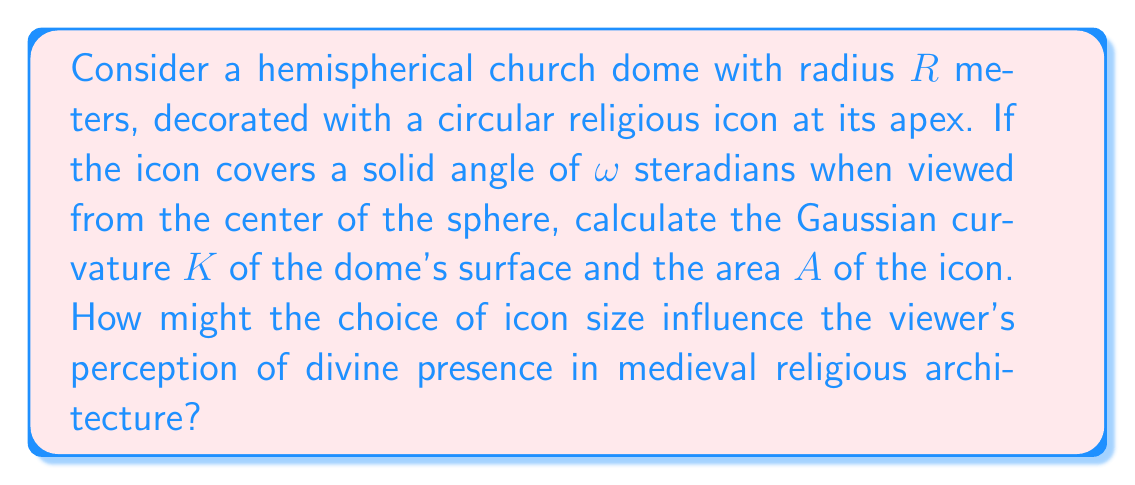Help me with this question. Let's approach this step-by-step:

1) The Gaussian curvature $K$ of a sphere is constant over its entire surface and is given by:

   $$K = \frac{1}{R^2}$$

   where $R$ is the radius of the sphere.

2) The area $A$ of a spherical cap (which our circular icon forms) is related to the solid angle $\omega$ it subtends and the radius $R$ of the sphere:

   $$A = \omega R^2$$

3) To understand the viewer's perception, we need to consider the ratio of the icon's area to the total area of the hemispherical dome:

   Total area of hemisphere: $A_{total} = 2\pi R^2$
   
   Ratio: $\frac{A}{A_{total}} = \frac{\omega R^2}{2\pi R^2} = \frac{\omega}{2\pi}$

4) This ratio is independent of the dome's size $R$, depending only on the solid angle $\omega$. A larger $\omega$ would make the icon appear more prominent, potentially enhancing the sense of divine presence.

5) In medieval iconography, the size and placement of religious symbols were often used to convey theological concepts. A larger icon at the apex of the dome might symbolize the omnipresence and supremacy of the divine, while a smaller one could emphasize the mystery and intangibility of the sacred.

[asy]
import geometry;

size(200);
pair O=(0,0);
real R=5;
draw(Circle(O,R));
real theta=pi/6;
draw(O--(-R*cos(theta),-R*sin(theta)));
draw(O--(R*cos(theta),-R*sin(theta)));
draw(arc(O,R,-90,-90+theta*180/pi),blue);
label("$R$",(R/2,0),E);
label("$\omega$",(0,0),N);
[/asy]
Answer: $K = \frac{1}{R^2}$; $A = \omega R^2$ 